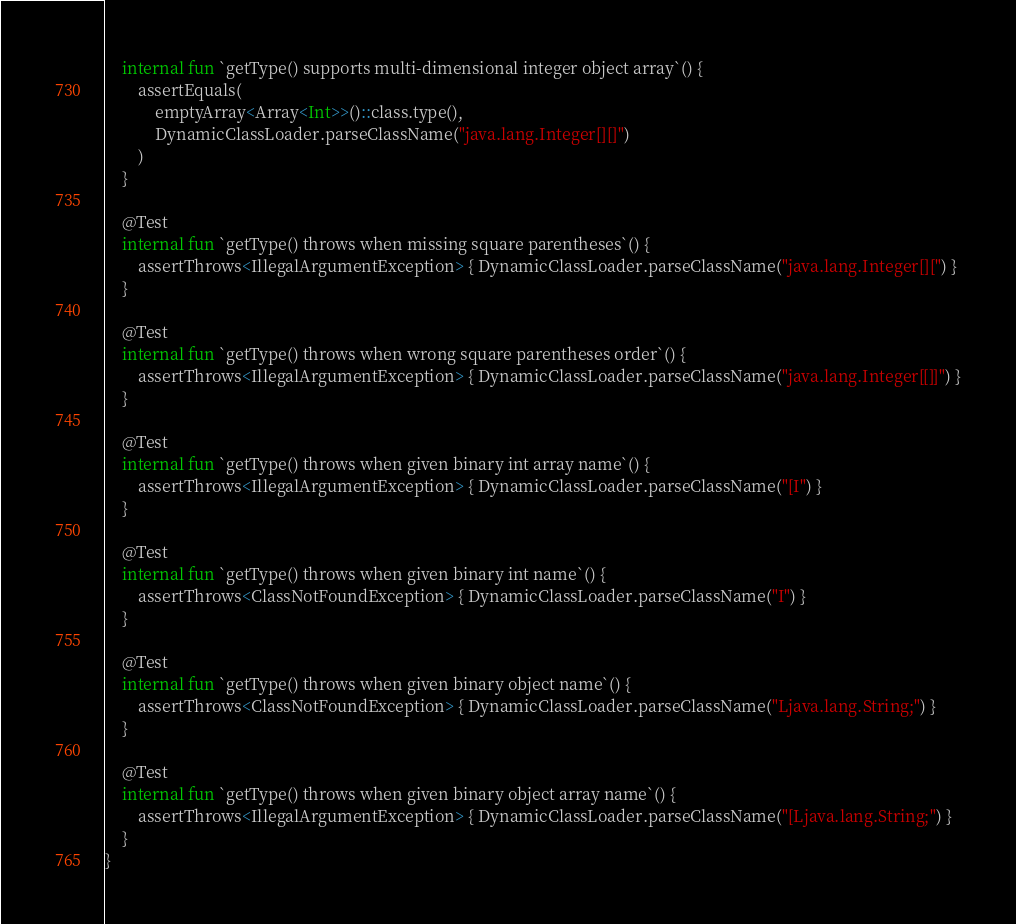<code> <loc_0><loc_0><loc_500><loc_500><_Kotlin_>    internal fun `getType() supports multi-dimensional integer object array`() {
        assertEquals(
            emptyArray<Array<Int>>()::class.type(),
            DynamicClassLoader.parseClassName("java.lang.Integer[][]")
        )
    }

    @Test
    internal fun `getType() throws when missing square parentheses`() {
        assertThrows<IllegalArgumentException> { DynamicClassLoader.parseClassName("java.lang.Integer[][") }
    }

    @Test
    internal fun `getType() throws when wrong square parentheses order`() {
        assertThrows<IllegalArgumentException> { DynamicClassLoader.parseClassName("java.lang.Integer[[]]") }
    }

    @Test
    internal fun `getType() throws when given binary int array name`() {
        assertThrows<IllegalArgumentException> { DynamicClassLoader.parseClassName("[I") }
    }

    @Test
    internal fun `getType() throws when given binary int name`() {
        assertThrows<ClassNotFoundException> { DynamicClassLoader.parseClassName("I") }
    }

    @Test
    internal fun `getType() throws when given binary object name`() {
        assertThrows<ClassNotFoundException> { DynamicClassLoader.parseClassName("Ljava.lang.String;") }
    }

    @Test
    internal fun `getType() throws when given binary object array name`() {
        assertThrows<IllegalArgumentException> { DynamicClassLoader.parseClassName("[Ljava.lang.String;") }
    }
}
</code> 